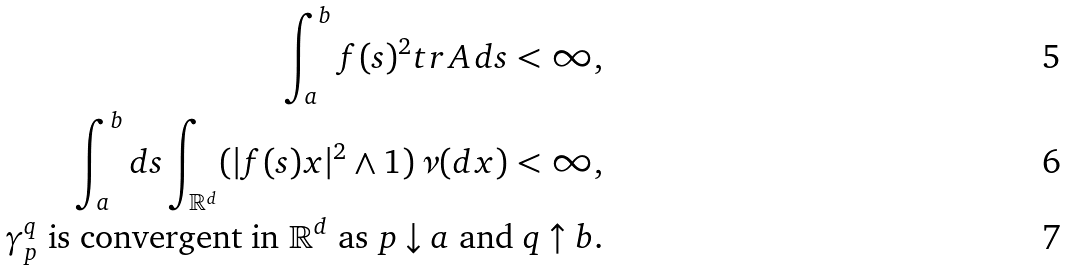<formula> <loc_0><loc_0><loc_500><loc_500>\int _ { a } ^ { b } f ( s ) ^ { 2 } t r \, A \, d s < \infty , \\ \int _ { a } ^ { b } d s \int _ { \mathbb { R } ^ { d } } ( | f ( s ) x | ^ { 2 } \land 1 ) \, \nu ( d x ) < \infty , \\ \text {$\gamma_{p}^{q}$ is convergent in $\mathbb{R}^{d}$ as $p\downarrow a$ and $q\uparrow b$.}</formula> 